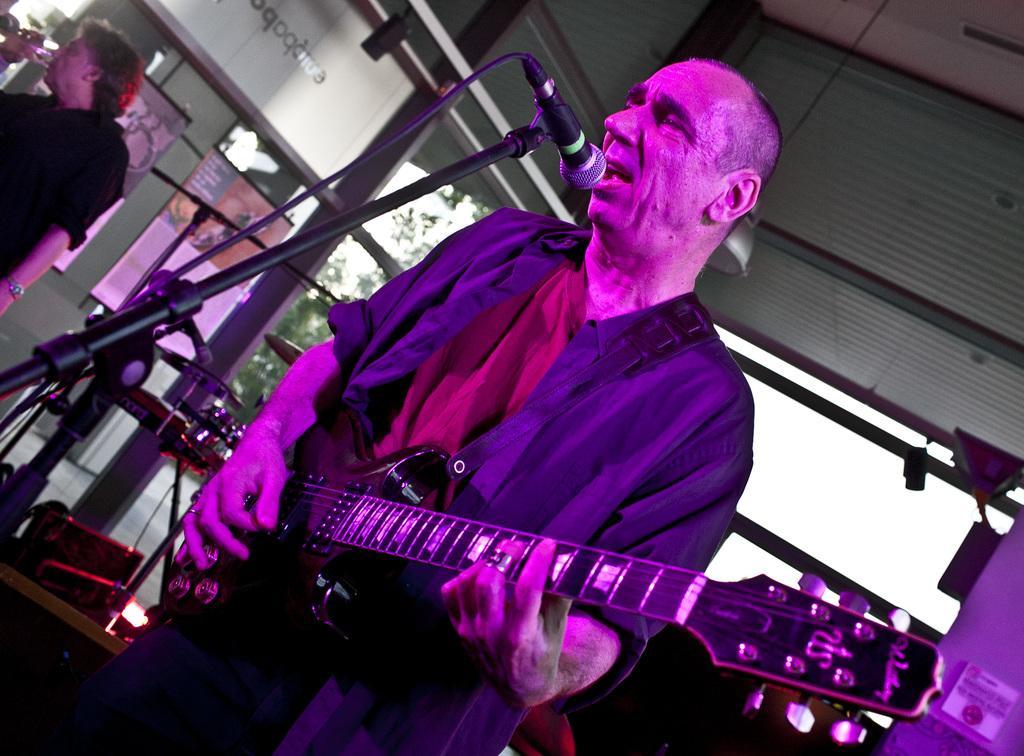Please provide a concise description of this image. In this image I can see a person is holding the guitar. In front I can see a mic,stand,one person is holding a glass. I can see trees and few banners attached to the glass. 